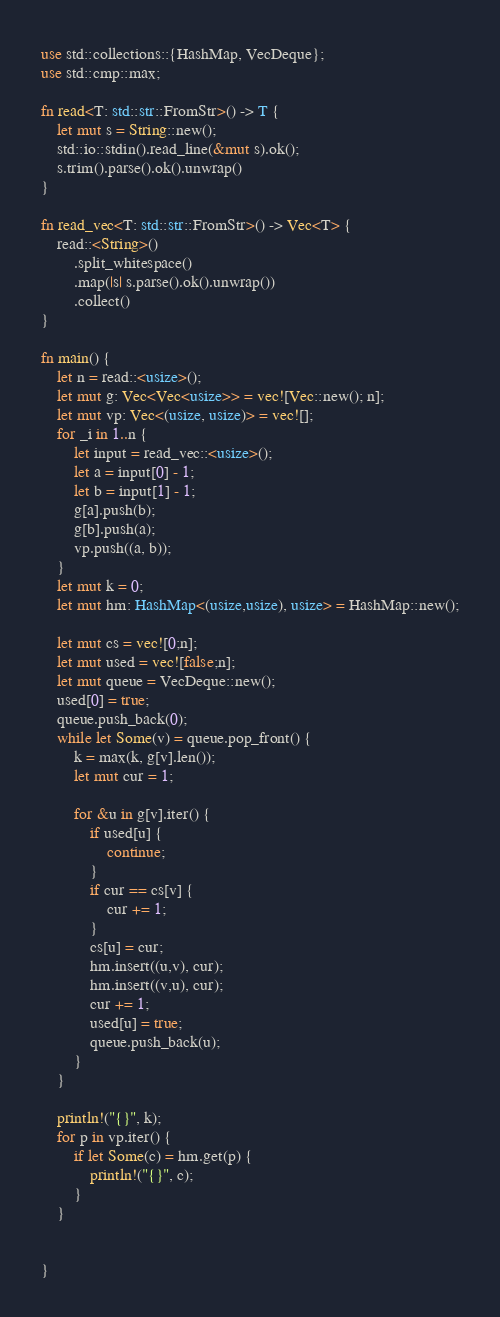Convert code to text. <code><loc_0><loc_0><loc_500><loc_500><_Rust_>use std::collections::{HashMap, VecDeque};
use std::cmp::max;

fn read<T: std::str::FromStr>() -> T {
    let mut s = String::new();
    std::io::stdin().read_line(&mut s).ok();
    s.trim().parse().ok().unwrap()
}

fn read_vec<T: std::str::FromStr>() -> Vec<T> {
    read::<String>()
        .split_whitespace()
        .map(|s| s.parse().ok().unwrap())
        .collect()
}

fn main() {
    let n = read::<usize>();
    let mut g: Vec<Vec<usize>> = vec![Vec::new(); n];
    let mut vp: Vec<(usize, usize)> = vec![];
    for _i in 1..n {
        let input = read_vec::<usize>();
        let a = input[0] - 1;
        let b = input[1] - 1;
        g[a].push(b);
        g[b].push(a);
        vp.push((a, b));
    }
    let mut k = 0;
    let mut hm: HashMap<(usize,usize), usize> = HashMap::new();

    let mut cs = vec![0;n];
    let mut used = vec![false;n];
    let mut queue = VecDeque::new();
    used[0] = true;
    queue.push_back(0);
    while let Some(v) = queue.pop_front() {
        k = max(k, g[v].len());
        let mut cur = 1;
        
        for &u in g[v].iter() {
            if used[u] {
                continue;
            }
            if cur == cs[v] {
                cur += 1;
            }
            cs[u] = cur;
            hm.insert((u,v), cur);
            hm.insert((v,u), cur);
            cur += 1;
            used[u] = true;
            queue.push_back(u);
        }
    }

    println!("{}", k);
    for p in vp.iter() {
        if let Some(c) = hm.get(p) {
            println!("{}", c);
        }
    }


}</code> 